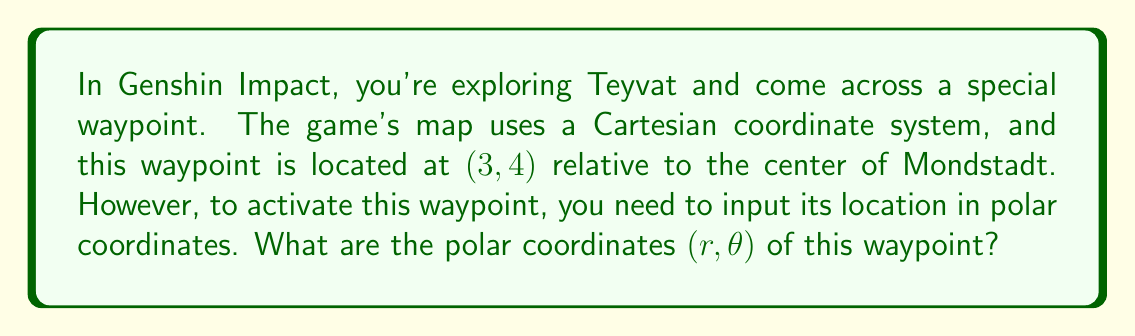What is the answer to this math problem? To solve this problem, we need to convert the Cartesian coordinates (x, y) = (3, 4) to polar coordinates (r, θ). Let's break this down step-by-step:

1. Calculate r:
   In polar coordinates, r represents the distance from the origin to the point. We can calculate this using the Pythagorean theorem:

   $$r = \sqrt{x^2 + y^2}$$
   $$r = \sqrt{3^2 + 4^2}$$
   $$r = \sqrt{9 + 16}$$
   $$r = \sqrt{25}$$
   $$r = 5$$

2. Calculate θ:
   θ represents the angle between the positive x-axis and the line from the origin to the point. We can calculate this using the arctangent function:

   $$\theta = \arctan(\frac{y}{x})$$
   $$\theta = \arctan(\frac{4}{3})$$
   $$\theta \approx 0.9273 \text{ radians}$$

   However, it's common to express θ in degrees for game inputs. To convert to degrees:

   $$\theta \text{ (in degrees)} = 0.9273 \times \frac{180^{\circ}}{\pi} \approx 53.13^{\circ}$$

Therefore, the polar coordinates are (5, 53.13°).

[asy]
import geometry;

size(200);
defaultpen(fontsize(10pt));

pair O=(0,0), P=(3,4);
draw((-1,0)--(4,0), arrow=Arrow(TeXHead));
draw((0,-1)--(0,5), arrow=Arrow(TeXHead));
draw(O--P, arrow=Arrow(TeXHead));
draw(arc(O,1,0,degrees(atan2(4,3))), L="θ");

dot(O);
dot(P);

label("O", O, SW);
label("P(3,4)", P, NE);
label("x", (4,0), S);
label("y", (0,5), W);
label("r", (1.5,2), NW);
[/asy]
Answer: The polar coordinates of the waypoint are $(r, \theta) = (5, 53.13^{\circ})$. 